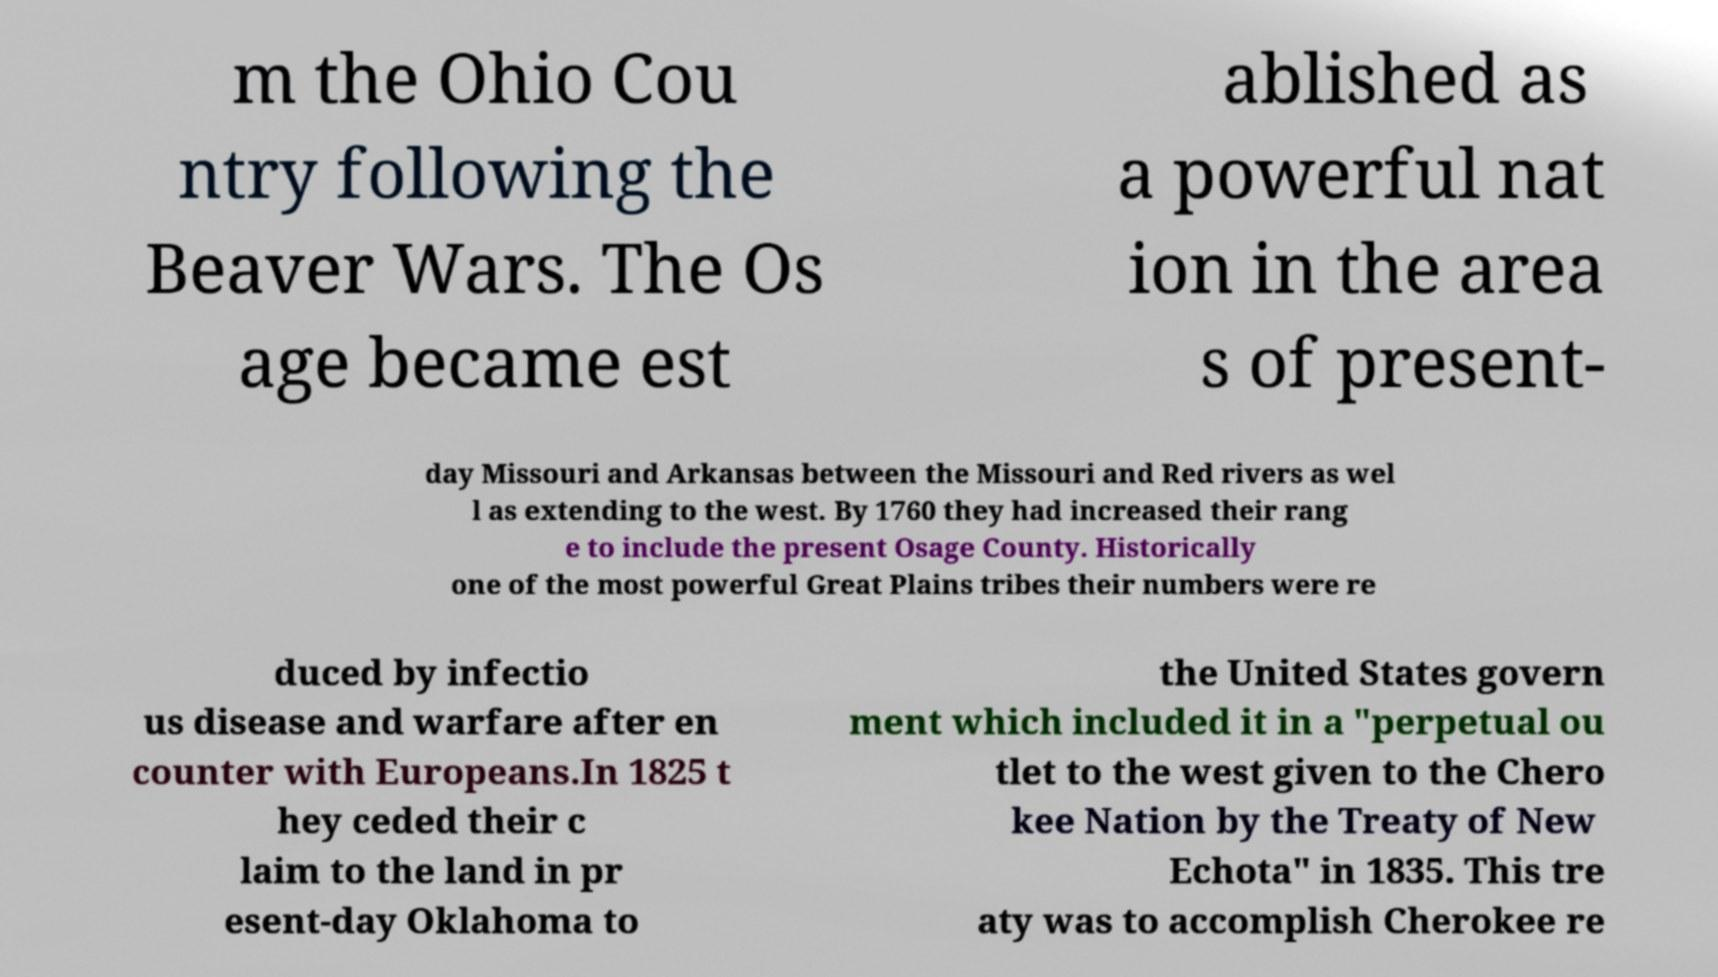Could you extract and type out the text from this image? m the Ohio Cou ntry following the Beaver Wars. The Os age became est ablished as a powerful nat ion in the area s of present- day Missouri and Arkansas between the Missouri and Red rivers as wel l as extending to the west. By 1760 they had increased their rang e to include the present Osage County. Historically one of the most powerful Great Plains tribes their numbers were re duced by infectio us disease and warfare after en counter with Europeans.In 1825 t hey ceded their c laim to the land in pr esent-day Oklahoma to the United States govern ment which included it in a "perpetual ou tlet to the west given to the Chero kee Nation by the Treaty of New Echota" in 1835. This tre aty was to accomplish Cherokee re 